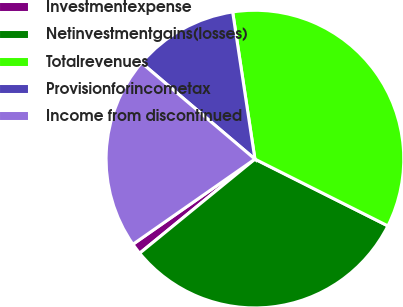Convert chart to OTSL. <chart><loc_0><loc_0><loc_500><loc_500><pie_chart><fcel>Investmentexpense<fcel>Netinvestmentgains(losses)<fcel>Totalrevenues<fcel>Provisionforincometax<fcel>Income from discontinued<nl><fcel>1.2%<fcel>31.69%<fcel>34.8%<fcel>11.41%<fcel>20.9%<nl></chart> 